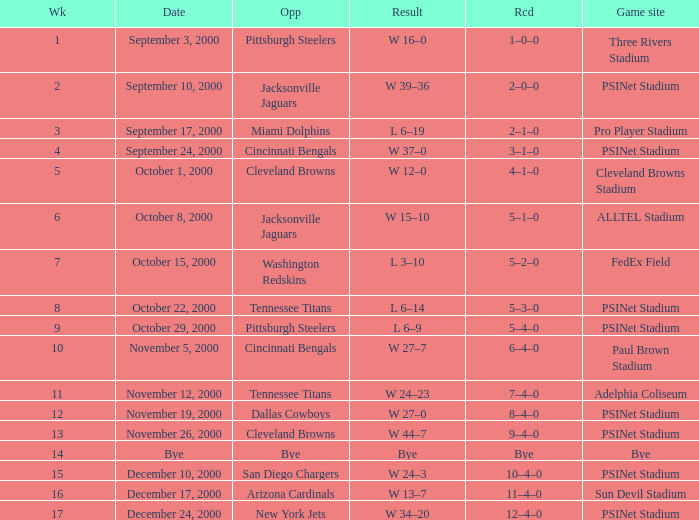What game site has a result of bye? Bye. 